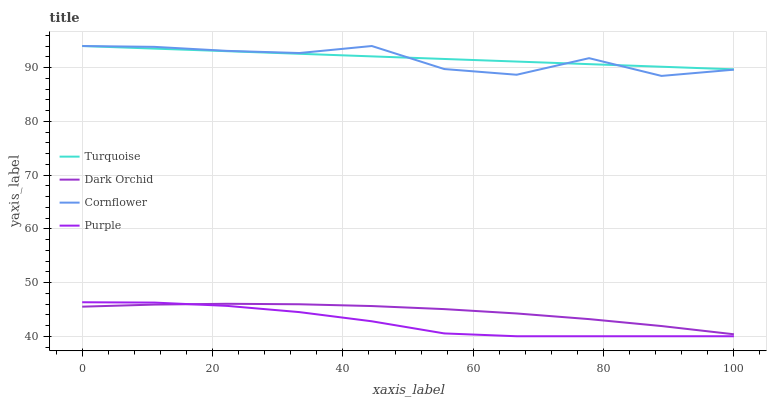Does Purple have the minimum area under the curve?
Answer yes or no. Yes. Does Turquoise have the maximum area under the curve?
Answer yes or no. Yes. Does Cornflower have the minimum area under the curve?
Answer yes or no. No. Does Cornflower have the maximum area under the curve?
Answer yes or no. No. Is Turquoise the smoothest?
Answer yes or no. Yes. Is Cornflower the roughest?
Answer yes or no. Yes. Is Cornflower the smoothest?
Answer yes or no. No. Is Turquoise the roughest?
Answer yes or no. No. Does Purple have the lowest value?
Answer yes or no. Yes. Does Cornflower have the lowest value?
Answer yes or no. No. Does Turquoise have the highest value?
Answer yes or no. Yes. Does Dark Orchid have the highest value?
Answer yes or no. No. Is Purple less than Cornflower?
Answer yes or no. Yes. Is Cornflower greater than Purple?
Answer yes or no. Yes. Does Turquoise intersect Cornflower?
Answer yes or no. Yes. Is Turquoise less than Cornflower?
Answer yes or no. No. Is Turquoise greater than Cornflower?
Answer yes or no. No. Does Purple intersect Cornflower?
Answer yes or no. No. 